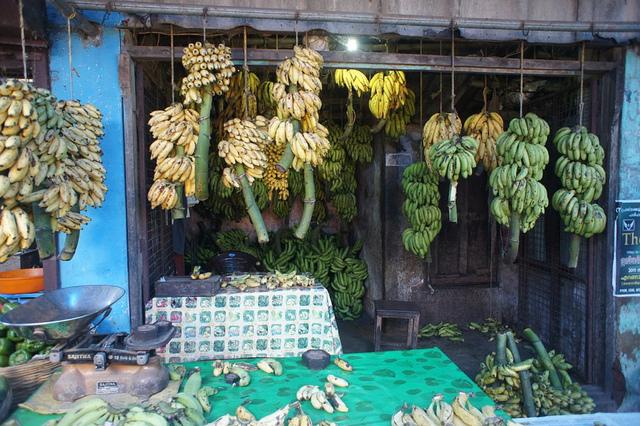How many tables?
Give a very brief answer. 2. What is hanging in the background?
Concise answer only. Bananas. What kind of fruit is hanging?
Keep it brief. Bananas. 